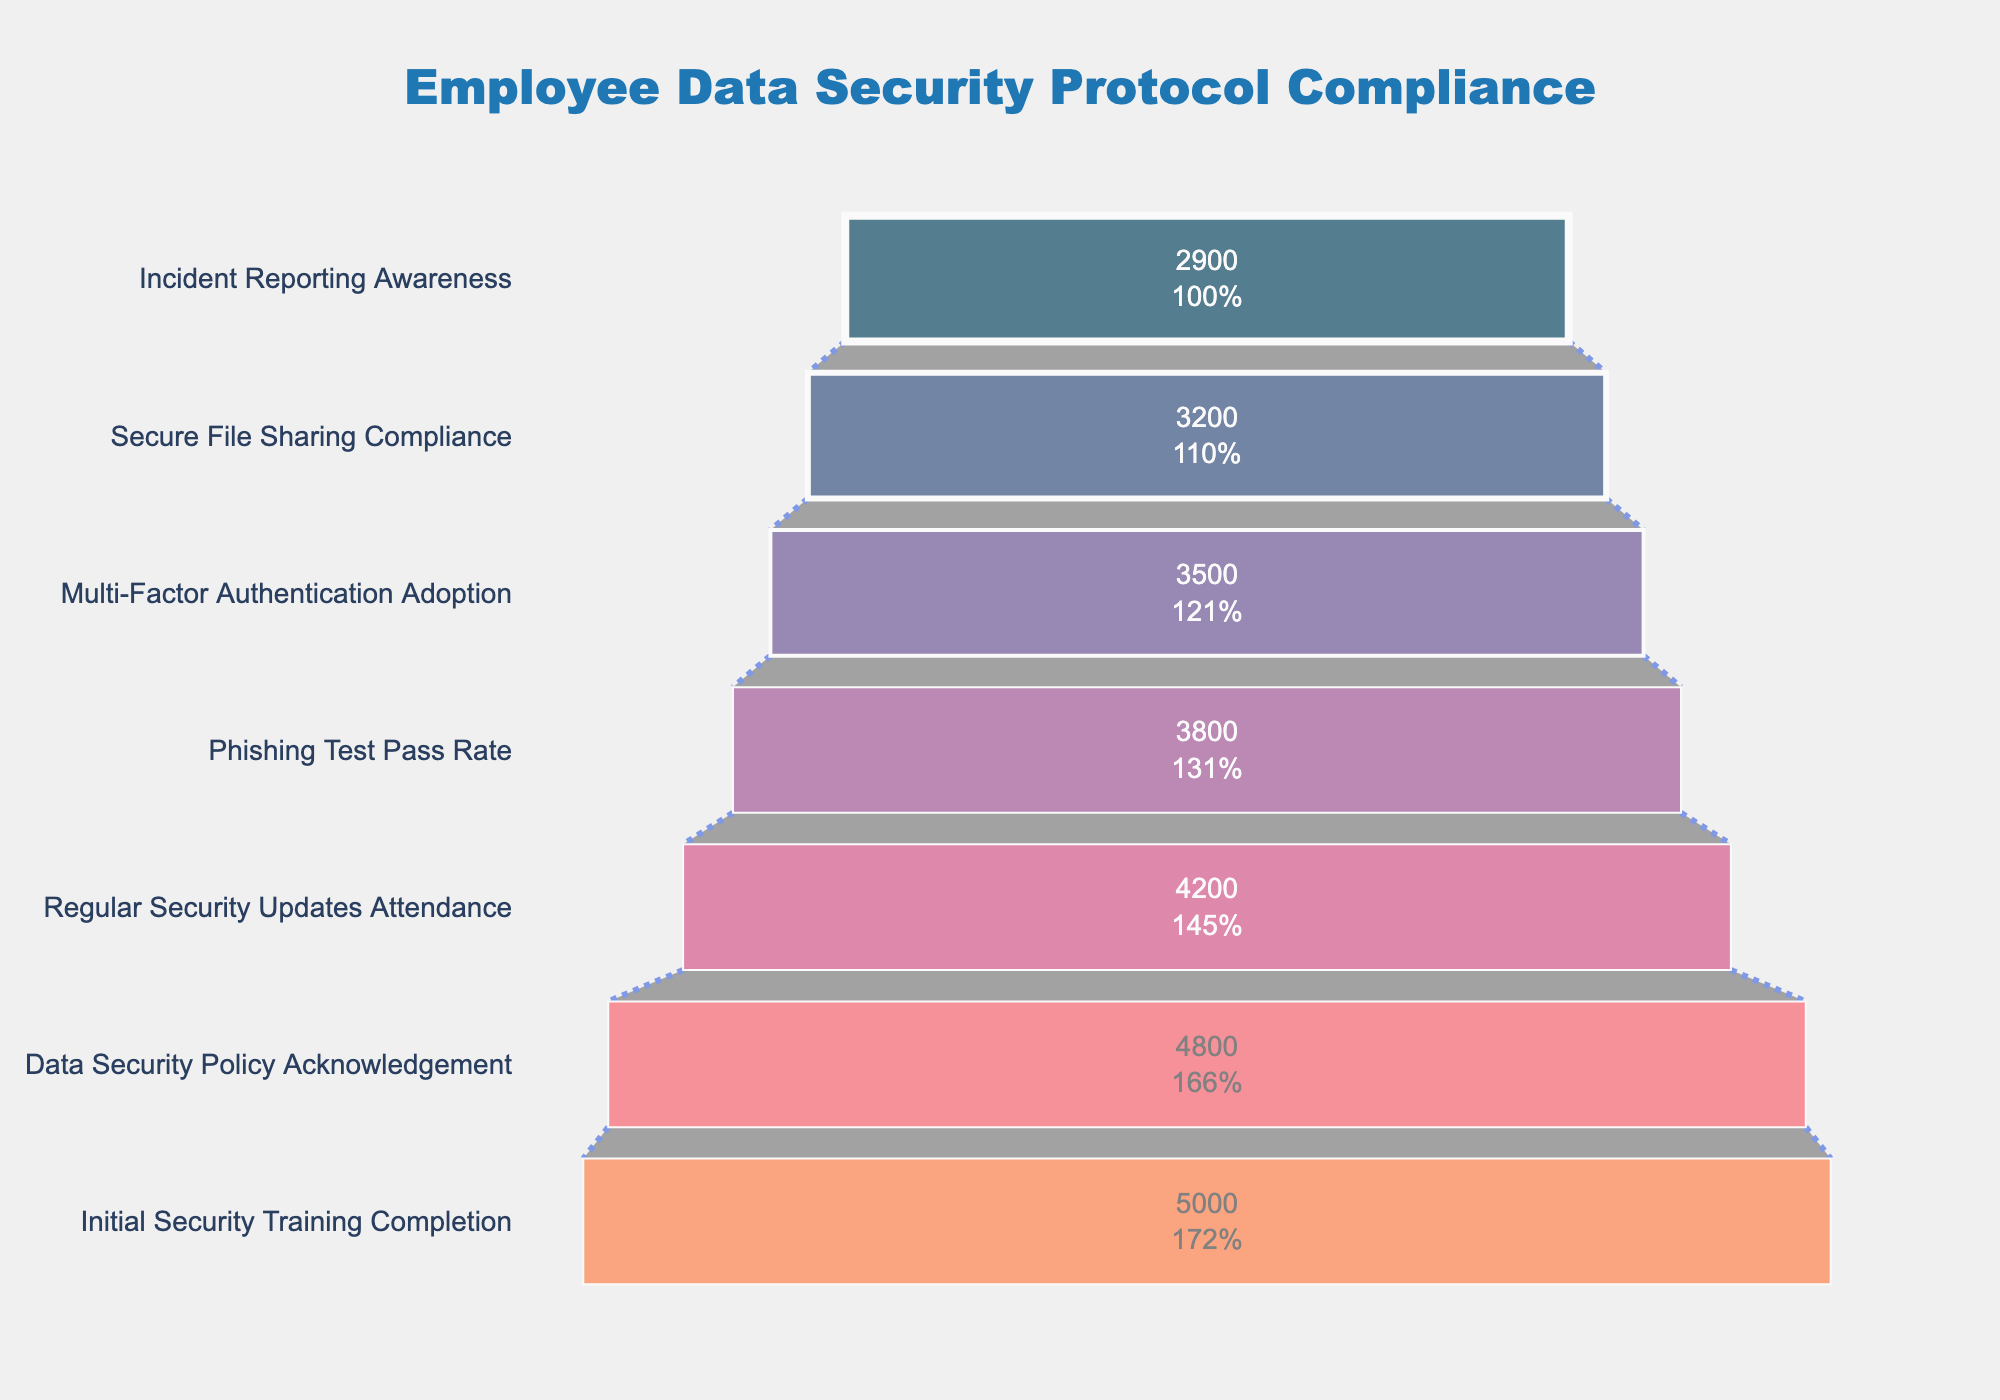What is the title of the funnel chart? The title is usually displayed at the top of the figure. Looking at the given plot, the title is set to "Employee Data Security Protocol Compliance".
Answer: Employee Data Security Protocol Compliance How many employees acknowledged the Data Security Policy? The funnel stage labeled "Data Security Policy Acknowledgement" shows the number of employees who acknowledged it. According to the data provided, this stage indicates 4,800 employees.
Answer: 4,800 What is the percentage drop from Initial Security Training Completion to Data Security Policy Acknowledgement? To find the percentage drop: (Initial - Acknowledgement) / Initial * 100. This translates to (5000 - 4800) / 5000 * 100 = 4%.
Answer: 4% Which stage has the lowest number of employees? The stage with the smallest value in the plot represents the lowest number of employees. "Incident Reporting Awareness" is the last funnel stage with the employee count of 2,900.
Answer: Incident Reporting Awareness What stages are included in the funnel chart? The stages are listed on the y-axis of the funnel chart. The stages are "Initial Security Training Completion", "Data Security Policy Acknowledgement", "Regular Security Updates Attendance", "Phishing Test Pass Rate", "Multi-Factor Authentication Adoption", "Secure File Sharing Compliance", and "Incident Reporting Awareness".
Answer: Initial Security Training Completion, Data Security Policy Acknowledgement, Regular Security Updates Attendance, Phishing Test Pass Rate, Multi-Factor Authentication Adoption, Secure File Sharing Compliance, Incident Reporting Awareness How many more employees completed Initial Security Training compared to those aware of Incident Reporting? Subtract the number of employees aware of Incident Reporting from those who completed Initial Security Training: 5000 - 2900 = 2100.
Answer: 2100 What's the average number of employees in the first three stages? Sum the employees in the first three stages and divide by three: (5000 + 4800 + 4200) / 3 = 13,000 / 3 = 4,333.33.
Answer: 4,333.33 What is the difference in employee count between Secure File Sharing Compliance and Phishing Test Pass Rate? Subtract the number of employees in Secure File Sharing Compliance from Phishing Test Pass Rate: 3800 - 3200 = 600.
Answer: 600 Which stage has the highest adoption rate? The stage with the highest number of employees indicates the highest adoption rate. "Initial Security Training Completion" has the highest number with 5,000 employees.
Answer: Initial Security Training Completion By how much does Multi-Factor Authentication Adoption exceed Secure File Sharing Compliance? Subtract the number of employees in Secure File Sharing Compliance from Multi-Factor Authentication Adoption: 3500 - 3200 = 300.
Answer: 300 